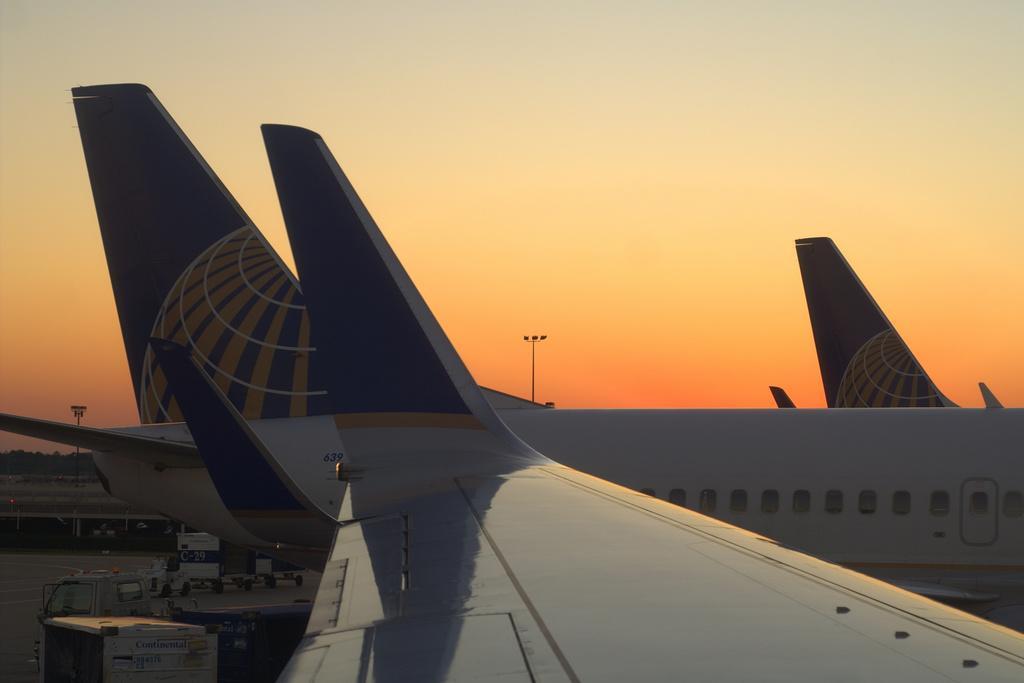In one or two sentences, can you explain what this image depicts? In this image we can see aeroplanes. At the left side bottom of the image there are vehicles. In the background of the image there is sky. 